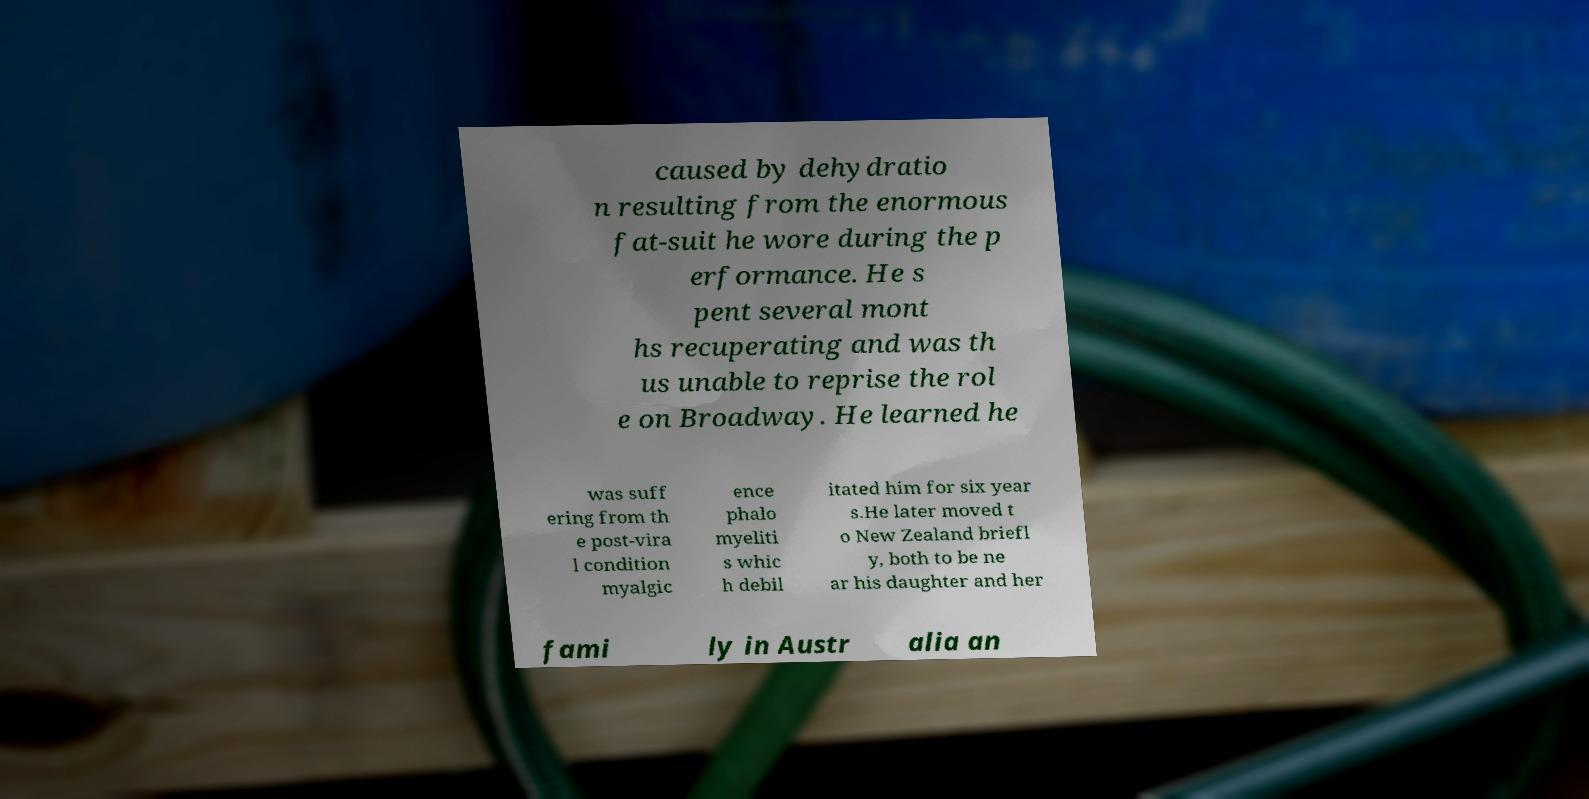There's text embedded in this image that I need extracted. Can you transcribe it verbatim? caused by dehydratio n resulting from the enormous fat-suit he wore during the p erformance. He s pent several mont hs recuperating and was th us unable to reprise the rol e on Broadway. He learned he was suff ering from th e post-vira l condition myalgic ence phalo myeliti s whic h debil itated him for six year s.He later moved t o New Zealand briefl y, both to be ne ar his daughter and her fami ly in Austr alia an 